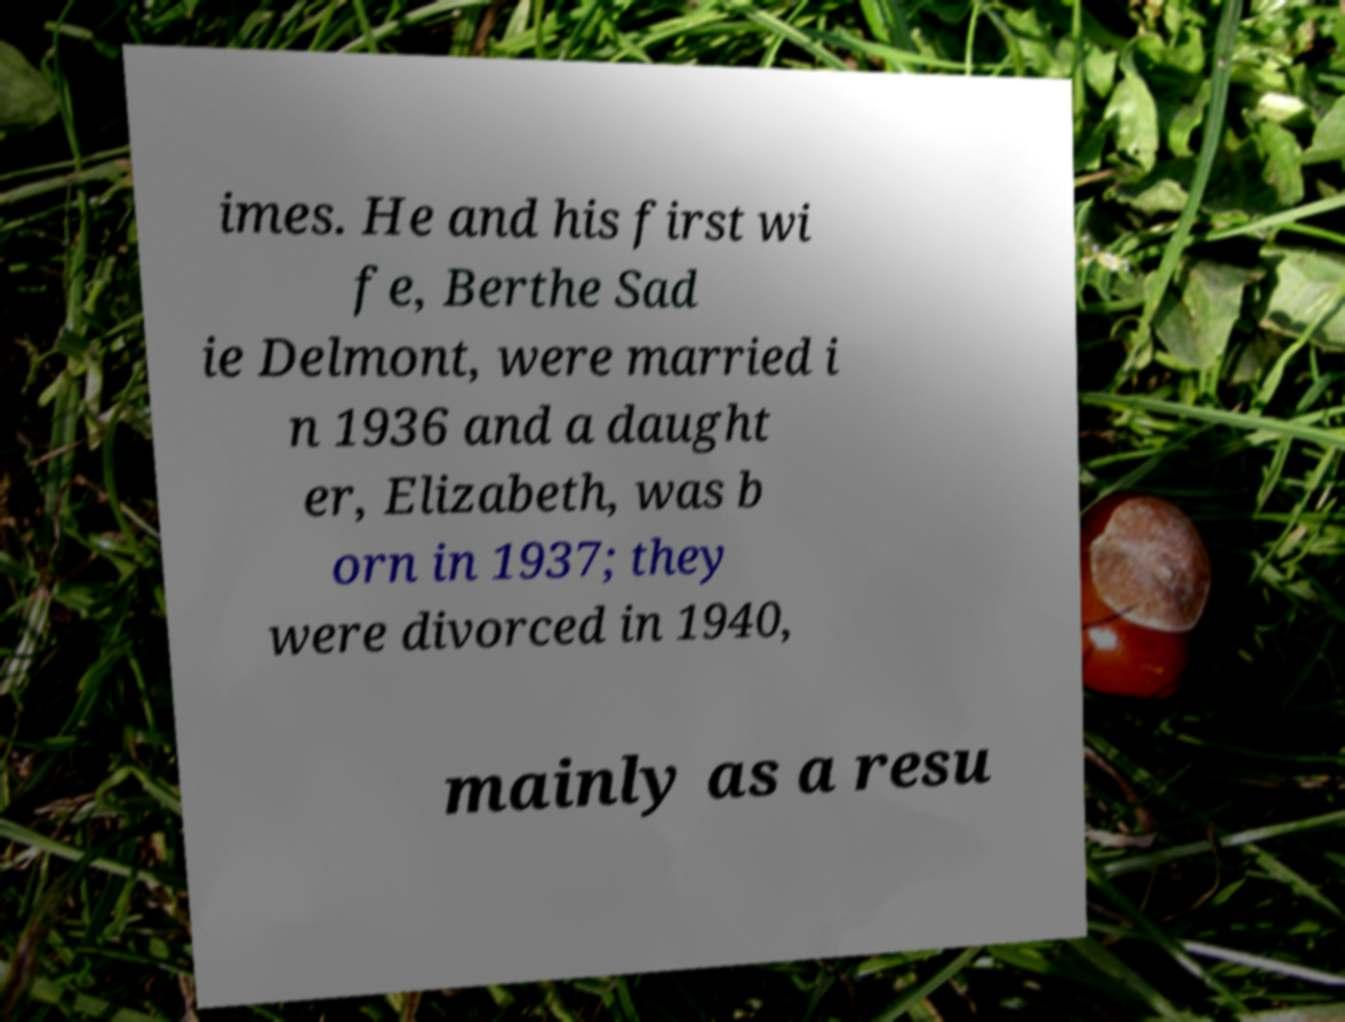I need the written content from this picture converted into text. Can you do that? imes. He and his first wi fe, Berthe Sad ie Delmont, were married i n 1936 and a daught er, Elizabeth, was b orn in 1937; they were divorced in 1940, mainly as a resu 